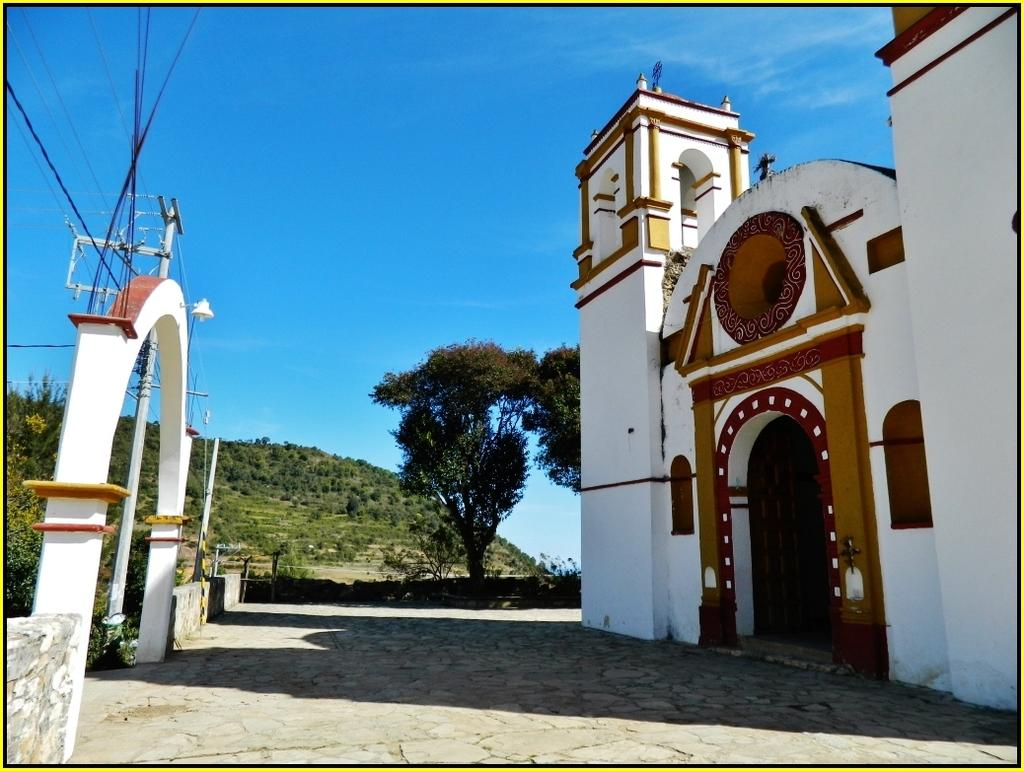What type of structure can be seen in the image? There is a building in the image. What architectural feature is present in the image? There is an arch in the image. What other objects can be seen in the image? Wires and poles are visible in the image. What can be seen in the background of the image? There are trees in the background of the image. What is the color of the sky in the image? The sky is blue in the image. How many crows are sitting on the wires in the image? There are no crows present in the image; only wires and poles can be seen. What type of kite is being flown by the ants in the image? There are no ants or kites present in the image. 